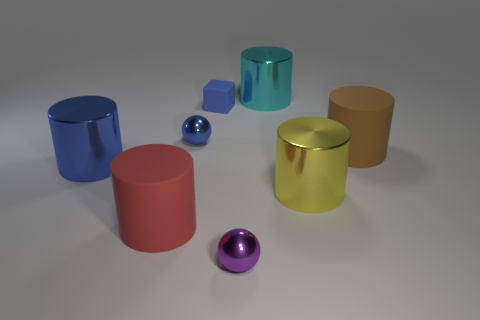How many objects are there in the image, and can you describe them? There are six objects in the image. Starting from the left, there is a blue cylinder, a red cylinder, a small blue cube, a blue metallic sphere, a cyan transparent cylinder, and a golden yellow cylinder. 